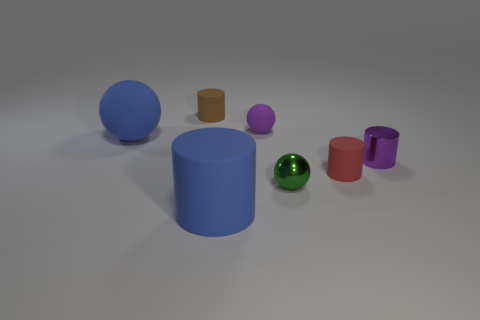What is the lighting like in the scene? The lighting in the image is soft and diffused, likely coming from above as indicated by the shadows cast directly beneath the objects. It's bright enough to illuminate the scene evenly without causing any harsh reflections or deep shadows. 